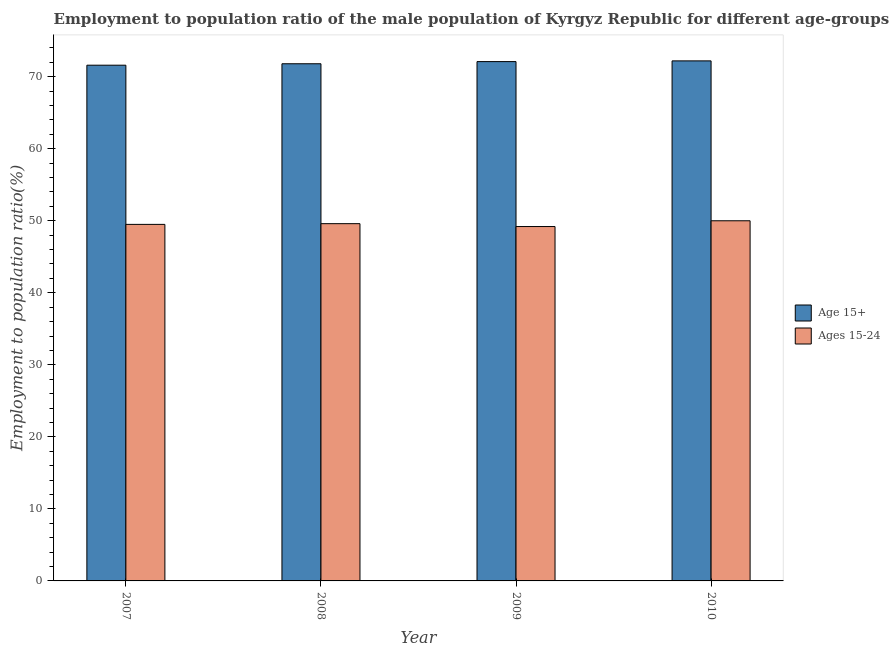How many bars are there on the 3rd tick from the right?
Give a very brief answer. 2. What is the label of the 1st group of bars from the left?
Make the answer very short. 2007. In how many cases, is the number of bars for a given year not equal to the number of legend labels?
Provide a succinct answer. 0. What is the employment to population ratio(age 15-24) in 2007?
Make the answer very short. 49.5. Across all years, what is the maximum employment to population ratio(age 15+)?
Your answer should be very brief. 72.2. Across all years, what is the minimum employment to population ratio(age 15+)?
Your answer should be very brief. 71.6. In which year was the employment to population ratio(age 15-24) minimum?
Ensure brevity in your answer.  2009. What is the total employment to population ratio(age 15-24) in the graph?
Ensure brevity in your answer.  198.3. What is the difference between the employment to population ratio(age 15+) in 2008 and that in 2010?
Keep it short and to the point. -0.4. What is the difference between the employment to population ratio(age 15-24) in 2008 and the employment to population ratio(age 15+) in 2010?
Your response must be concise. -0.4. What is the average employment to population ratio(age 15+) per year?
Your answer should be very brief. 71.92. In the year 2010, what is the difference between the employment to population ratio(age 15+) and employment to population ratio(age 15-24)?
Provide a short and direct response. 0. What is the ratio of the employment to population ratio(age 15+) in 2007 to that in 2008?
Ensure brevity in your answer.  1. Is the difference between the employment to population ratio(age 15+) in 2009 and 2010 greater than the difference between the employment to population ratio(age 15-24) in 2009 and 2010?
Offer a terse response. No. What is the difference between the highest and the second highest employment to population ratio(age 15-24)?
Offer a very short reply. 0.4. What is the difference between the highest and the lowest employment to population ratio(age 15-24)?
Provide a succinct answer. 0.8. What does the 1st bar from the left in 2008 represents?
Provide a short and direct response. Age 15+. What does the 2nd bar from the right in 2009 represents?
Your answer should be compact. Age 15+. How many bars are there?
Provide a succinct answer. 8. What is the difference between two consecutive major ticks on the Y-axis?
Offer a terse response. 10. Does the graph contain any zero values?
Your answer should be compact. No. Where does the legend appear in the graph?
Provide a succinct answer. Center right. How are the legend labels stacked?
Offer a terse response. Vertical. What is the title of the graph?
Make the answer very short. Employment to population ratio of the male population of Kyrgyz Republic for different age-groups. What is the Employment to population ratio(%) of Age 15+ in 2007?
Your response must be concise. 71.6. What is the Employment to population ratio(%) of Ages 15-24 in 2007?
Provide a succinct answer. 49.5. What is the Employment to population ratio(%) in Age 15+ in 2008?
Your response must be concise. 71.8. What is the Employment to population ratio(%) in Ages 15-24 in 2008?
Offer a terse response. 49.6. What is the Employment to population ratio(%) in Age 15+ in 2009?
Offer a terse response. 72.1. What is the Employment to population ratio(%) in Ages 15-24 in 2009?
Ensure brevity in your answer.  49.2. What is the Employment to population ratio(%) of Age 15+ in 2010?
Offer a terse response. 72.2. What is the Employment to population ratio(%) of Ages 15-24 in 2010?
Ensure brevity in your answer.  50. Across all years, what is the maximum Employment to population ratio(%) of Age 15+?
Your answer should be compact. 72.2. Across all years, what is the maximum Employment to population ratio(%) of Ages 15-24?
Provide a short and direct response. 50. Across all years, what is the minimum Employment to population ratio(%) in Age 15+?
Provide a succinct answer. 71.6. Across all years, what is the minimum Employment to population ratio(%) in Ages 15-24?
Make the answer very short. 49.2. What is the total Employment to population ratio(%) in Age 15+ in the graph?
Provide a short and direct response. 287.7. What is the total Employment to population ratio(%) of Ages 15-24 in the graph?
Ensure brevity in your answer.  198.3. What is the difference between the Employment to population ratio(%) of Age 15+ in 2007 and that in 2008?
Keep it short and to the point. -0.2. What is the difference between the Employment to population ratio(%) in Age 15+ in 2007 and that in 2009?
Your answer should be compact. -0.5. What is the difference between the Employment to population ratio(%) in Ages 15-24 in 2007 and that in 2010?
Provide a short and direct response. -0.5. What is the difference between the Employment to population ratio(%) in Age 15+ in 2008 and that in 2009?
Ensure brevity in your answer.  -0.3. What is the difference between the Employment to population ratio(%) in Ages 15-24 in 2008 and that in 2009?
Your response must be concise. 0.4. What is the difference between the Employment to population ratio(%) in Age 15+ in 2008 and that in 2010?
Offer a very short reply. -0.4. What is the difference between the Employment to population ratio(%) in Ages 15-24 in 2008 and that in 2010?
Your response must be concise. -0.4. What is the difference between the Employment to population ratio(%) of Ages 15-24 in 2009 and that in 2010?
Provide a succinct answer. -0.8. What is the difference between the Employment to population ratio(%) of Age 15+ in 2007 and the Employment to population ratio(%) of Ages 15-24 in 2009?
Provide a succinct answer. 22.4. What is the difference between the Employment to population ratio(%) in Age 15+ in 2007 and the Employment to population ratio(%) in Ages 15-24 in 2010?
Your answer should be very brief. 21.6. What is the difference between the Employment to population ratio(%) in Age 15+ in 2008 and the Employment to population ratio(%) in Ages 15-24 in 2009?
Provide a succinct answer. 22.6. What is the difference between the Employment to population ratio(%) in Age 15+ in 2008 and the Employment to population ratio(%) in Ages 15-24 in 2010?
Your response must be concise. 21.8. What is the difference between the Employment to population ratio(%) of Age 15+ in 2009 and the Employment to population ratio(%) of Ages 15-24 in 2010?
Keep it short and to the point. 22.1. What is the average Employment to population ratio(%) in Age 15+ per year?
Offer a very short reply. 71.92. What is the average Employment to population ratio(%) of Ages 15-24 per year?
Provide a short and direct response. 49.58. In the year 2007, what is the difference between the Employment to population ratio(%) of Age 15+ and Employment to population ratio(%) of Ages 15-24?
Your answer should be very brief. 22.1. In the year 2009, what is the difference between the Employment to population ratio(%) in Age 15+ and Employment to population ratio(%) in Ages 15-24?
Offer a very short reply. 22.9. What is the ratio of the Employment to population ratio(%) in Age 15+ in 2007 to that in 2009?
Give a very brief answer. 0.99. What is the ratio of the Employment to population ratio(%) in Ages 15-24 in 2007 to that in 2009?
Give a very brief answer. 1.01. What is the ratio of the Employment to population ratio(%) of Age 15+ in 2008 to that in 2009?
Provide a short and direct response. 1. What is the ratio of the Employment to population ratio(%) in Ages 15-24 in 2008 to that in 2009?
Offer a very short reply. 1.01. What is the ratio of the Employment to population ratio(%) of Age 15+ in 2008 to that in 2010?
Make the answer very short. 0.99. What is the ratio of the Employment to population ratio(%) of Ages 15-24 in 2008 to that in 2010?
Give a very brief answer. 0.99. What is the ratio of the Employment to population ratio(%) in Age 15+ in 2009 to that in 2010?
Your response must be concise. 1. What is the ratio of the Employment to population ratio(%) in Ages 15-24 in 2009 to that in 2010?
Provide a succinct answer. 0.98. What is the difference between the highest and the second highest Employment to population ratio(%) of Age 15+?
Offer a very short reply. 0.1. What is the difference between the highest and the second highest Employment to population ratio(%) in Ages 15-24?
Provide a short and direct response. 0.4. What is the difference between the highest and the lowest Employment to population ratio(%) of Age 15+?
Give a very brief answer. 0.6. What is the difference between the highest and the lowest Employment to population ratio(%) of Ages 15-24?
Keep it short and to the point. 0.8. 